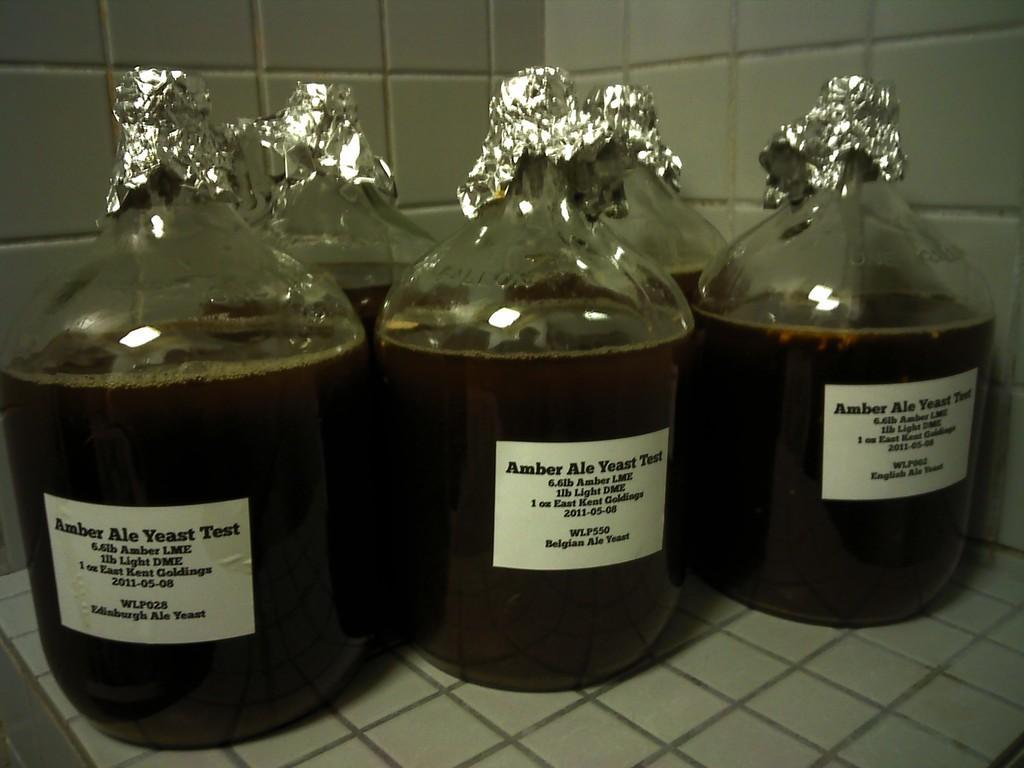In one or two sentences, can you explain what this image depicts? This image consists of five bottles in which there is a brown color liquid and there is something written and passed on these bottles. Aluminium foil is covered on the top of every bottle. 